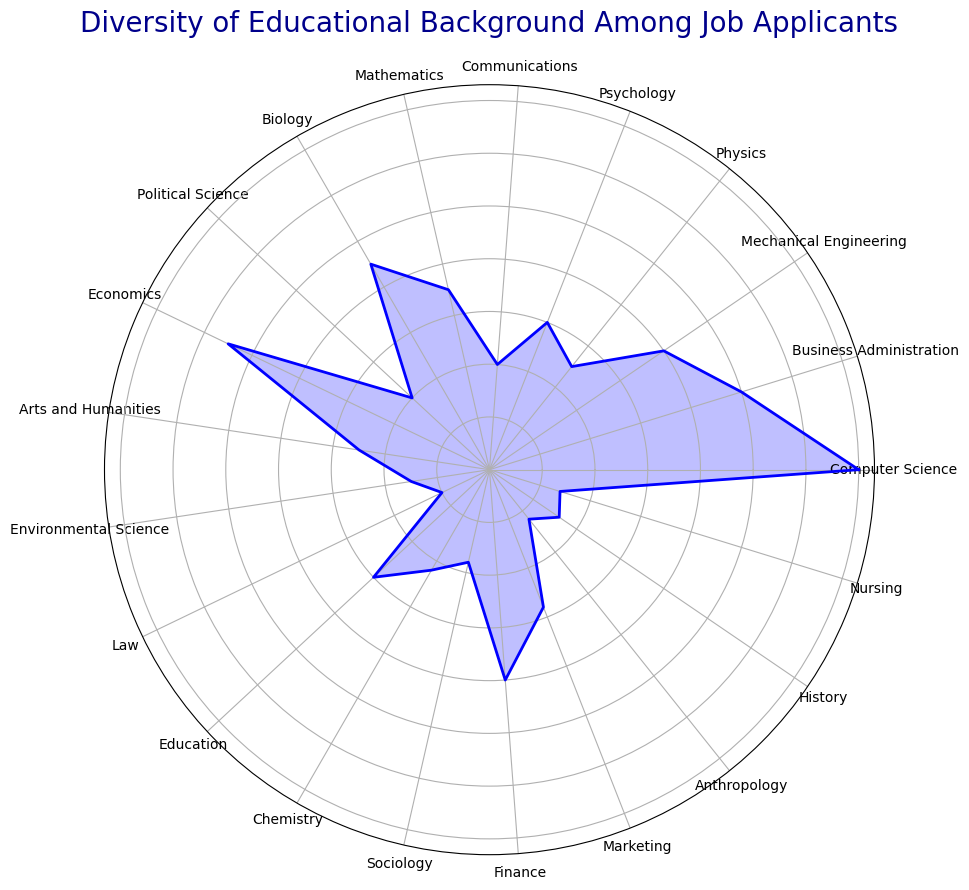Which educational background has the highest number of job applicants? The slice of the rose chart with the greatest radius corresponds to the educational background with the highest number of job applicants. In this figure, the 'Computer Science' slice has the largest radius.
Answer: Computer Science Which educational background has the lowest number of job applicants? The slice of the rose chart with the smallest radius corresponds to the educational background with the lowest number of job applicants. In this figure, the 'Law' slice has the smallest radius.
Answer: Law How many more applicants are there from Computer Science compared to Law? The number of applicants from Computer Science (70) and from Law (10) are represented by the lengths of the corresponding slices. The difference is calculated as 70 - 10.
Answer: 60 What is the total number of job applicants from STEM (Science, Technology, Engineering, Mathematics) fields? Count the applicants from Computer Science (70), Mechanical Engineering (40), Mathematics (35), Biology (45), Physics (25), Chemistry (22), Environmental Science (15), and Nursing (14). Sum them to get the total: 70 + 40 + 35 + 45 + 25 + 22 + 15 + 14.
Answer: 266 Does Business Administration have more or fewer applicants than Economics? Compare the lengths of the slices for Business Administration and Economics. Business Administration has 50 applicants whereas Economics has 55 applicants, so Business Administration has fewer applicants.
Answer: Fewer Which field has more applicants, Psychology or Social Sciences combined (Sociology, Political Science, and Anthropology)? Count the applicants from Psychology (30). For Social Sciences, add the counts from Sociology (18), Political Science (20), and Anthropology (12): 18 + 20 + 12 = 50. Compare 30 and 50.
Answer: Social Sciences If we combine the number of applicants from Communications and Arts and Humanities, do we get a higher number than Business Administration? Add the counts from Communications (20) and Arts and Humanities (25): 20 + 25 = 45. Compare 45 to Business Administration (50).
Answer: No What is the combined percentage of applicants from Computer Science and Mechanical Engineering? First, find the total number of all applicants: 70 + 50 + 40 + 25 + 30 + 20 + 35 + 45 + 20 + 55 + 25 + 15 + 10 + 30 + 22 + 18 + 40 + 28 + 12 + 16 + 14 = 590. Combine Computer Science (70) and Mechanical Engineering (40): 70 + 40 = 110. Calculate the percentage: (110 / 590) * 100.
Answer: 18.64% Which has more applicants: the combined fields of Education, Nursing, and Law, or Physics? Add the counts from Education (30), Nursing (14), and Law (10): 30 + 14 + 10 = 54. Compare this total with Physics (25).
Answer: Education, Nursing, and Law Estimate the proportion of applicants from Finance and Marketing combined to the total number of applicants. Add the counts from Finance (40) and Marketing (28): 40 + 28 = 68. The total number of applicants is 590. Calculate the proportion: 68 / 590.
Answer: 0.115 